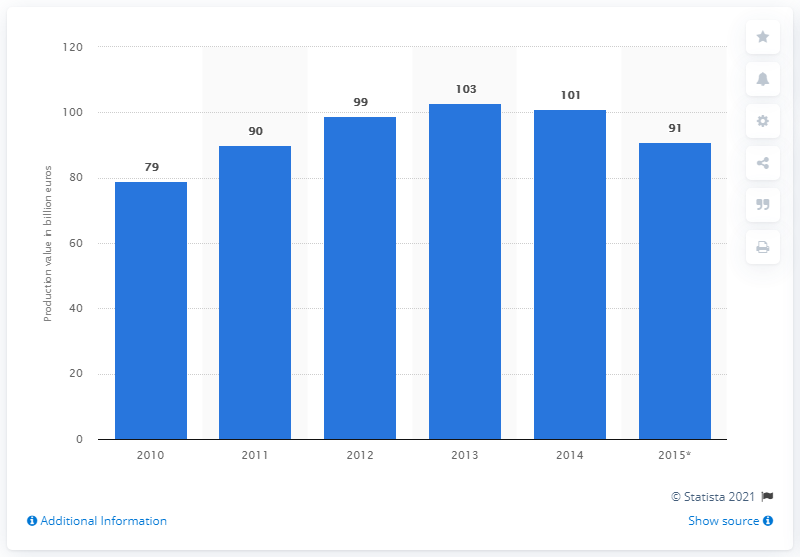Give some essential details in this illustration. In the year 2013, the value of farming machinery surpassed 103 billion euros. According to data from 2013, the value of farming machinery was approximately 103. 